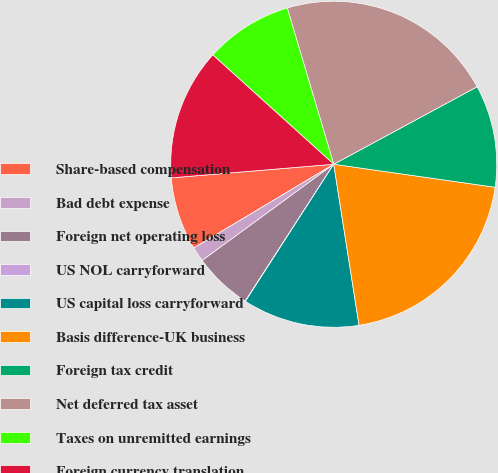Convert chart. <chart><loc_0><loc_0><loc_500><loc_500><pie_chart><fcel>Share-based compensation<fcel>Bad debt expense<fcel>Foreign net operating loss<fcel>US NOL carryforward<fcel>US capital loss carryforward<fcel>Basis difference-UK business<fcel>Foreign tax credit<fcel>Net deferred tax asset<fcel>Taxes on unremitted earnings<fcel>Foreign currency translation<nl><fcel>7.25%<fcel>1.47%<fcel>5.81%<fcel>0.03%<fcel>11.59%<fcel>20.26%<fcel>10.14%<fcel>21.71%<fcel>8.7%<fcel>13.03%<nl></chart> 